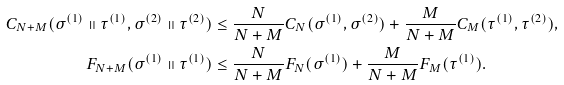<formula> <loc_0><loc_0><loc_500><loc_500>C _ { N + M } ( \sigma ^ { ( 1 ) } \shortparallel \tau ^ { ( 1 ) } , \sigma ^ { ( 2 ) } \shortparallel \tau ^ { ( 2 ) } ) & \leq \frac { N } { N + M } C _ { N } ( \sigma ^ { ( 1 ) } , \sigma ^ { ( 2 ) } ) + \frac { M } { N + M } C _ { M } ( \tau ^ { ( 1 ) } , \tau ^ { ( 2 ) } ) , \\ F _ { N + M } ( \sigma ^ { ( 1 ) } \shortparallel \tau ^ { ( 1 ) } ) & \leq \frac { N } { N + M } F _ { N } ( \sigma ^ { ( 1 ) } ) + \frac { M } { N + M } F _ { M } ( \tau ^ { ( 1 ) } ) .</formula> 